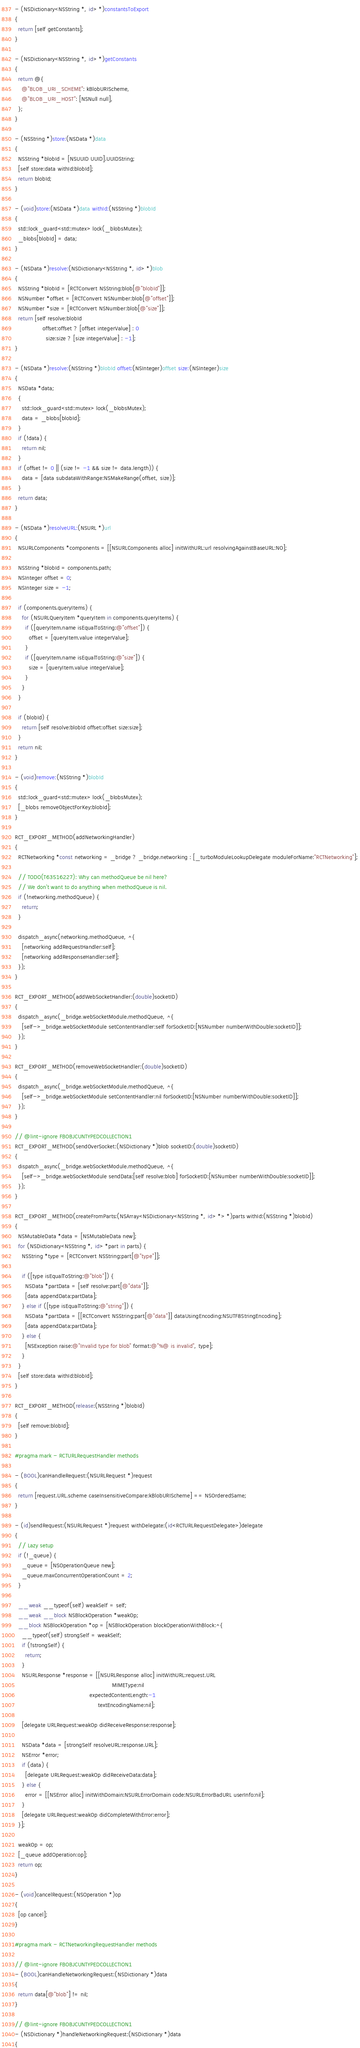Convert code to text. <code><loc_0><loc_0><loc_500><loc_500><_ObjectiveC_>
- (NSDictionary<NSString *, id> *)constantsToExport
{
  return [self getConstants];
}

- (NSDictionary<NSString *, id> *)getConstants
{
  return @{
    @"BLOB_URI_SCHEME": kBlobURIScheme,
    @"BLOB_URI_HOST": [NSNull null],
  };
}

- (NSString *)store:(NSData *)data
{
  NSString *blobId = [NSUUID UUID].UUIDString;
  [self store:data withId:blobId];
  return blobId;
}

- (void)store:(NSData *)data withId:(NSString *)blobId
{
  std::lock_guard<std::mutex> lock(_blobsMutex);
  _blobs[blobId] = data;
}

- (NSData *)resolve:(NSDictionary<NSString *, id> *)blob
{
  NSString *blobId = [RCTConvert NSString:blob[@"blobId"]];
  NSNumber *offset = [RCTConvert NSNumber:blob[@"offset"]];
  NSNumber *size = [RCTConvert NSNumber:blob[@"size"]];
  return [self resolve:blobId
                offset:offset ? [offset integerValue] : 0
                  size:size ? [size integerValue] : -1];
}

- (NSData *)resolve:(NSString *)blobId offset:(NSInteger)offset size:(NSInteger)size
{
  NSData *data;
  {
    std::lock_guard<std::mutex> lock(_blobsMutex);
    data = _blobs[blobId];
  }
  if (!data) {
    return nil;
  }
  if (offset != 0 || (size != -1 && size != data.length)) {
    data = [data subdataWithRange:NSMakeRange(offset, size)];
  }
  return data;
}

- (NSData *)resolveURL:(NSURL *)url
{
  NSURLComponents *components = [[NSURLComponents alloc] initWithURL:url resolvingAgainstBaseURL:NO];

  NSString *blobId = components.path;
  NSInteger offset = 0;
  NSInteger size = -1;

  if (components.queryItems) {
    for (NSURLQueryItem *queryItem in components.queryItems) {
      if ([queryItem.name isEqualToString:@"offset"]) {
        offset = [queryItem.value integerValue];
      }
      if ([queryItem.name isEqualToString:@"size"]) {
        size = [queryItem.value integerValue];
      }
    }
  }

  if (blobId) {
    return [self resolve:blobId offset:offset size:size];
  }
  return nil;
}

- (void)remove:(NSString *)blobId
{
  std::lock_guard<std::mutex> lock(_blobsMutex);
  [_blobs removeObjectForKey:blobId];
}

RCT_EXPORT_METHOD(addNetworkingHandler)
{
  RCTNetworking *const networking = _bridge ? _bridge.networking : [_turboModuleLookupDelegate moduleForName:"RCTNetworking"];

  // TODO(T63516227): Why can methodQueue be nil here? 
  // We don't want to do anything when methodQueue is nil.
  if (!networking.methodQueue) {
    return;
  }

  dispatch_async(networking.methodQueue, ^{
    [networking addRequestHandler:self];
    [networking addResponseHandler:self];
  });
}

RCT_EXPORT_METHOD(addWebSocketHandler:(double)socketID)
{
  dispatch_async(_bridge.webSocketModule.methodQueue, ^{
    [self->_bridge.webSocketModule setContentHandler:self forSocketID:[NSNumber numberWithDouble:socketID]];
  });
}

RCT_EXPORT_METHOD(removeWebSocketHandler:(double)socketID)
{
  dispatch_async(_bridge.webSocketModule.methodQueue, ^{
    [self->_bridge.webSocketModule setContentHandler:nil forSocketID:[NSNumber numberWithDouble:socketID]];
  });
}

// @lint-ignore FBOBJCUNTYPEDCOLLECTION1
RCT_EXPORT_METHOD(sendOverSocket:(NSDictionary *)blob socketID:(double)socketID)
{
  dispatch_async(_bridge.webSocketModule.methodQueue, ^{
    [self->_bridge.webSocketModule sendData:[self resolve:blob] forSocketID:[NSNumber numberWithDouble:socketID]];
  });
}

RCT_EXPORT_METHOD(createFromParts:(NSArray<NSDictionary<NSString *, id> *> *)parts withId:(NSString *)blobId)
{
  NSMutableData *data = [NSMutableData new];
  for (NSDictionary<NSString *, id> *part in parts) {
    NSString *type = [RCTConvert NSString:part[@"type"]];

    if ([type isEqualToString:@"blob"]) {
      NSData *partData = [self resolve:part[@"data"]];
      [data appendData:partData];
    } else if ([type isEqualToString:@"string"]) {
      NSData *partData = [[RCTConvert NSString:part[@"data"]] dataUsingEncoding:NSUTF8StringEncoding];
      [data appendData:partData];
    } else {
      [NSException raise:@"Invalid type for blob" format:@"%@ is invalid", type];
    }
  }
  [self store:data withId:blobId];
}

RCT_EXPORT_METHOD(release:(NSString *)blobId)
{
  [self remove:blobId];
}

#pragma mark - RCTURLRequestHandler methods

- (BOOL)canHandleRequest:(NSURLRequest *)request
{
  return [request.URL.scheme caseInsensitiveCompare:kBlobURIScheme] == NSOrderedSame;
}

- (id)sendRequest:(NSURLRequest *)request withDelegate:(id<RCTURLRequestDelegate>)delegate
{
  // Lazy setup
  if (!_queue) {
    _queue = [NSOperationQueue new];
    _queue.maxConcurrentOperationCount = 2;
  }

  __weak __typeof(self) weakSelf = self;
  __weak __block NSBlockOperation *weakOp;
  __block NSBlockOperation *op = [NSBlockOperation blockOperationWithBlock:^{
    __typeof(self) strongSelf = weakSelf;
    if (!strongSelf) {
      return;
    }
    NSURLResponse *response = [[NSURLResponse alloc] initWithURL:request.URL
                                                        MIMEType:nil
                                           expectedContentLength:-1
                                                textEncodingName:nil];

    [delegate URLRequest:weakOp didReceiveResponse:response];

    NSData *data = [strongSelf resolveURL:response.URL];
    NSError *error;
    if (data) {
      [delegate URLRequest:weakOp didReceiveData:data];
    } else {
      error = [[NSError alloc] initWithDomain:NSURLErrorDomain code:NSURLErrorBadURL userInfo:nil];
    }
    [delegate URLRequest:weakOp didCompleteWithError:error];
  }];

  weakOp = op;
  [_queue addOperation:op];
  return op;
}

- (void)cancelRequest:(NSOperation *)op
{
  [op cancel];
}

#pragma mark - RCTNetworkingRequestHandler methods

// @lint-ignore FBOBJCUNTYPEDCOLLECTION1
- (BOOL)canHandleNetworkingRequest:(NSDictionary *)data
{
  return data[@"blob"] != nil;
}

// @lint-ignore FBOBJCUNTYPEDCOLLECTION1
- (NSDictionary *)handleNetworkingRequest:(NSDictionary *)data
{</code> 